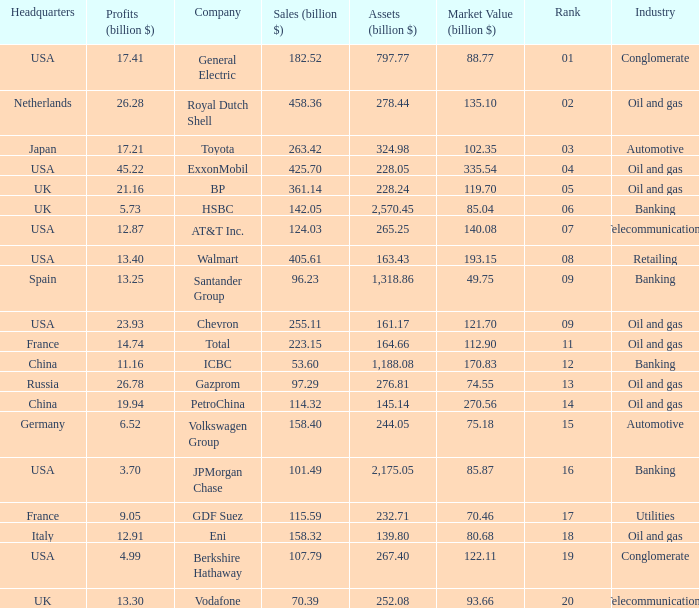Name the highest Profits (billion $) which has a Company of walmart? 13.4. 